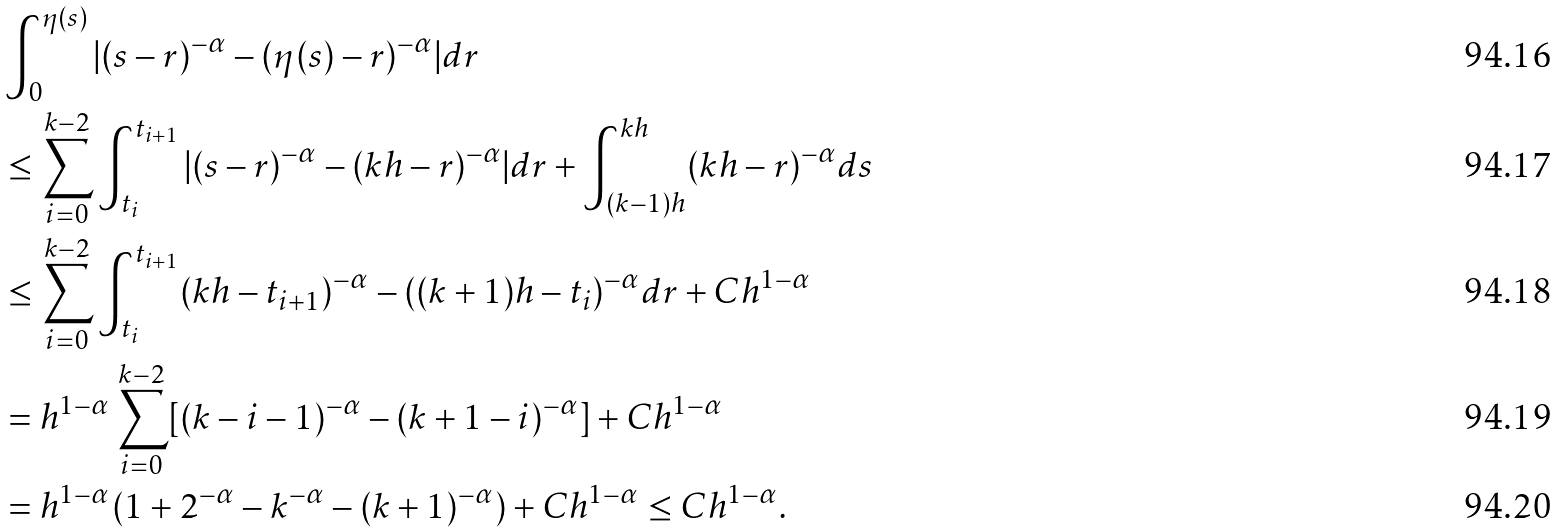<formula> <loc_0><loc_0><loc_500><loc_500>& \int _ { 0 } ^ { \eta ( s ) } | ( s - r ) ^ { - \alpha } - ( \eta ( s ) - r ) ^ { - \alpha } | d r \\ & \leq \sum _ { i = 0 } ^ { k - 2 } \int _ { t _ { i } } ^ { t _ { i + 1 } } | ( s - r ) ^ { - \alpha } - ( k h - r ) ^ { - \alpha } | d r + \int _ { ( k - 1 ) h } ^ { k h } ( k h - r ) ^ { - \alpha } d s \\ & \leq \sum _ { i = 0 } ^ { k - 2 } \int _ { t _ { i } } ^ { t _ { i + 1 } } ( k h - t _ { i + 1 } ) ^ { - \alpha } - ( ( k + 1 ) h - t _ { i } ) ^ { - \alpha } d r + C h ^ { 1 - \alpha } \\ & = h ^ { 1 - \alpha } \sum _ { i = 0 } ^ { k - 2 } [ ( k - i - 1 ) ^ { - \alpha } - ( k + 1 - i ) ^ { - \alpha } ] + C h ^ { 1 - \alpha } \\ & = h ^ { 1 - \alpha } ( 1 + 2 ^ { - \alpha } - k ^ { - \alpha } - ( k + 1 ) ^ { - \alpha } ) + C h ^ { 1 - \alpha } \leq C h ^ { 1 - \alpha } .</formula> 